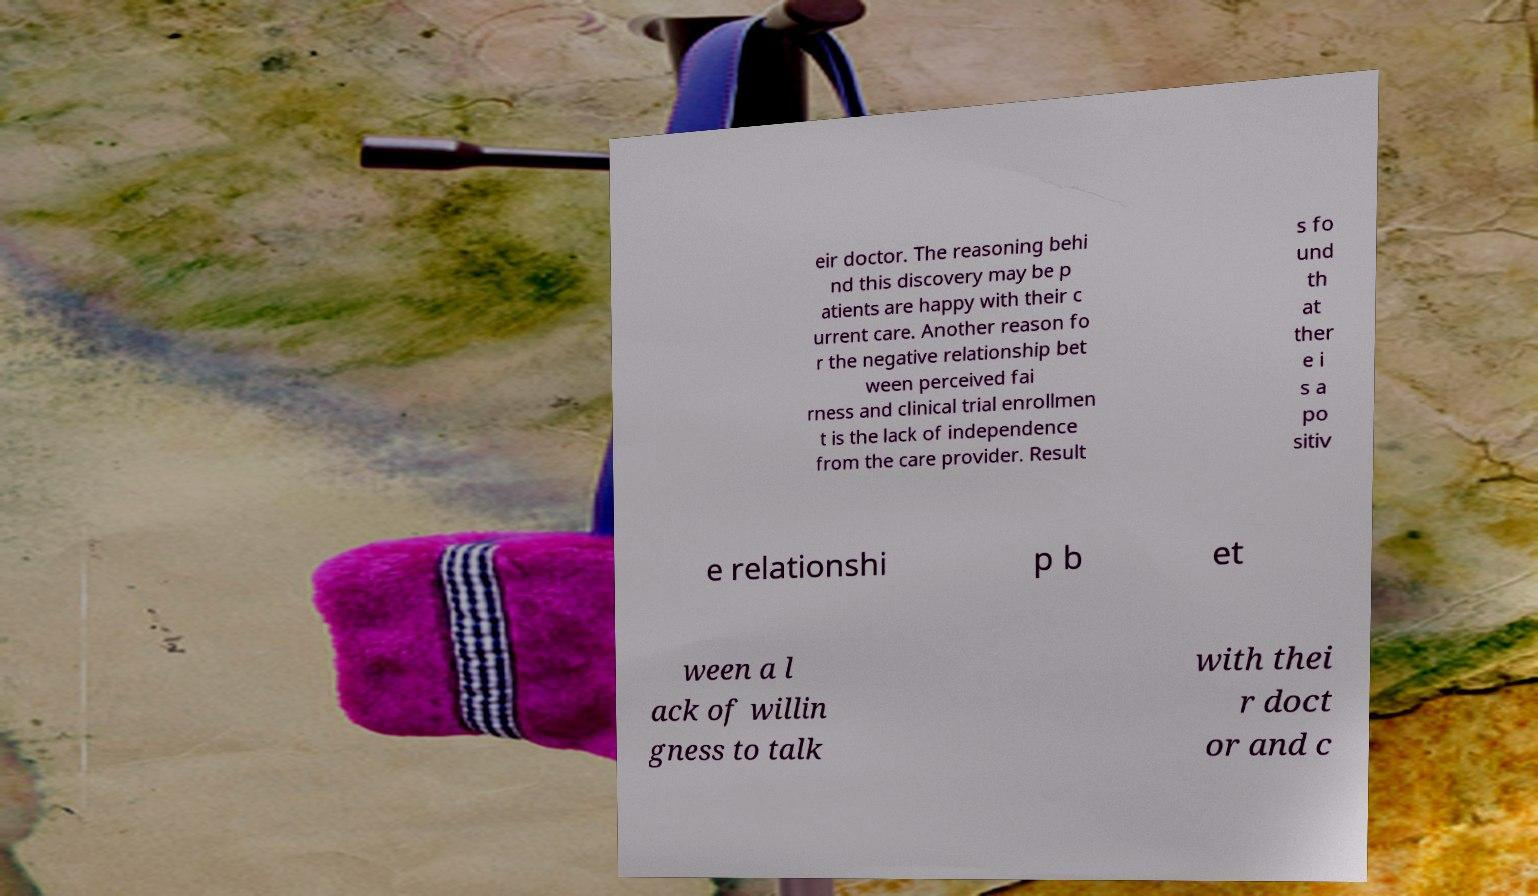For documentation purposes, I need the text within this image transcribed. Could you provide that? eir doctor. The reasoning behi nd this discovery may be p atients are happy with their c urrent care. Another reason fo r the negative relationship bet ween perceived fai rness and clinical trial enrollmen t is the lack of independence from the care provider. Result s fo und th at ther e i s a po sitiv e relationshi p b et ween a l ack of willin gness to talk with thei r doct or and c 